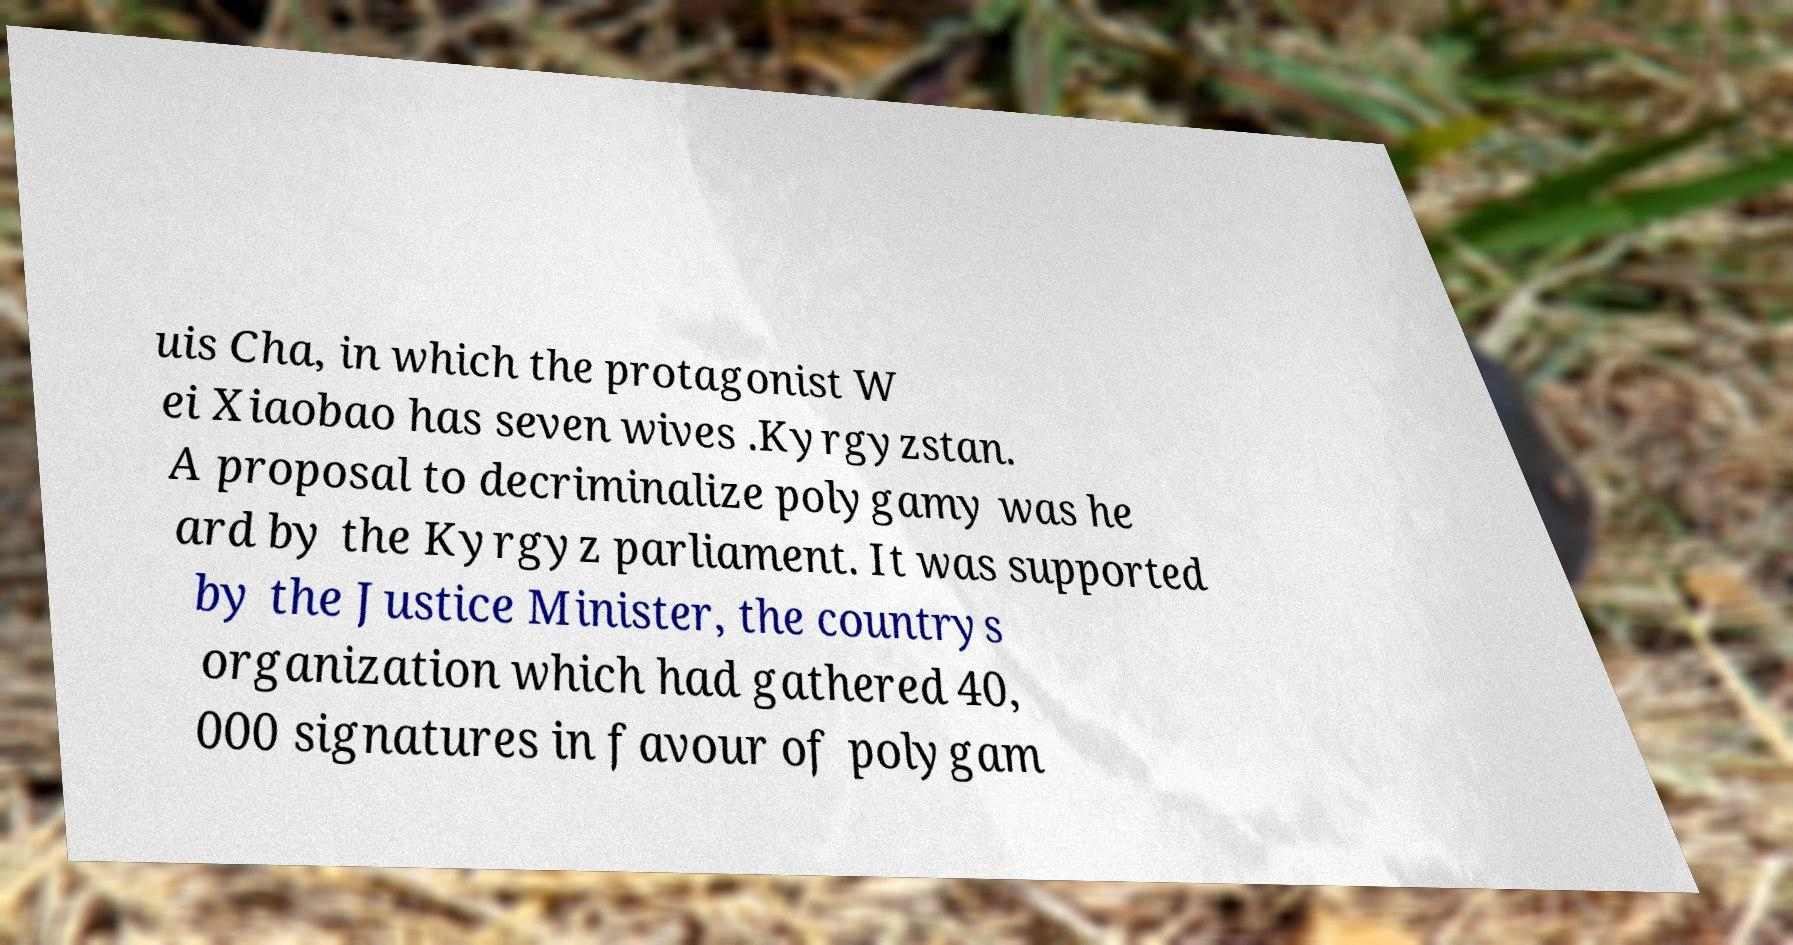There's text embedded in this image that I need extracted. Can you transcribe it verbatim? uis Cha, in which the protagonist W ei Xiaobao has seven wives .Kyrgyzstan. A proposal to decriminalize polygamy was he ard by the Kyrgyz parliament. It was supported by the Justice Minister, the countrys organization which had gathered 40, 000 signatures in favour of polygam 